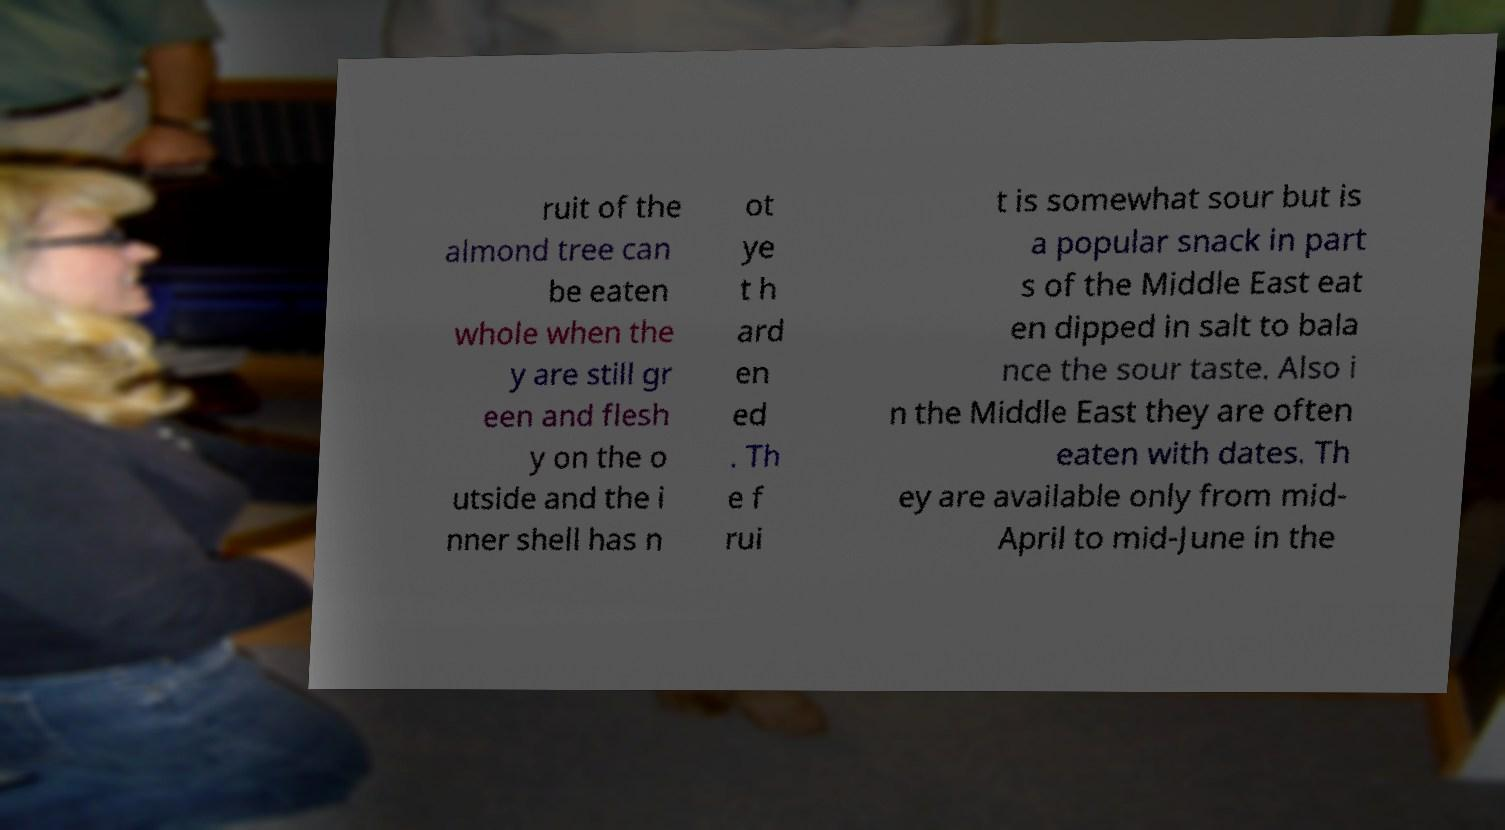Can you read and provide the text displayed in the image?This photo seems to have some interesting text. Can you extract and type it out for me? ruit of the almond tree can be eaten whole when the y are still gr een and flesh y on the o utside and the i nner shell has n ot ye t h ard en ed . Th e f rui t is somewhat sour but is a popular snack in part s of the Middle East eat en dipped in salt to bala nce the sour taste. Also i n the Middle East they are often eaten with dates. Th ey are available only from mid- April to mid-June in the 